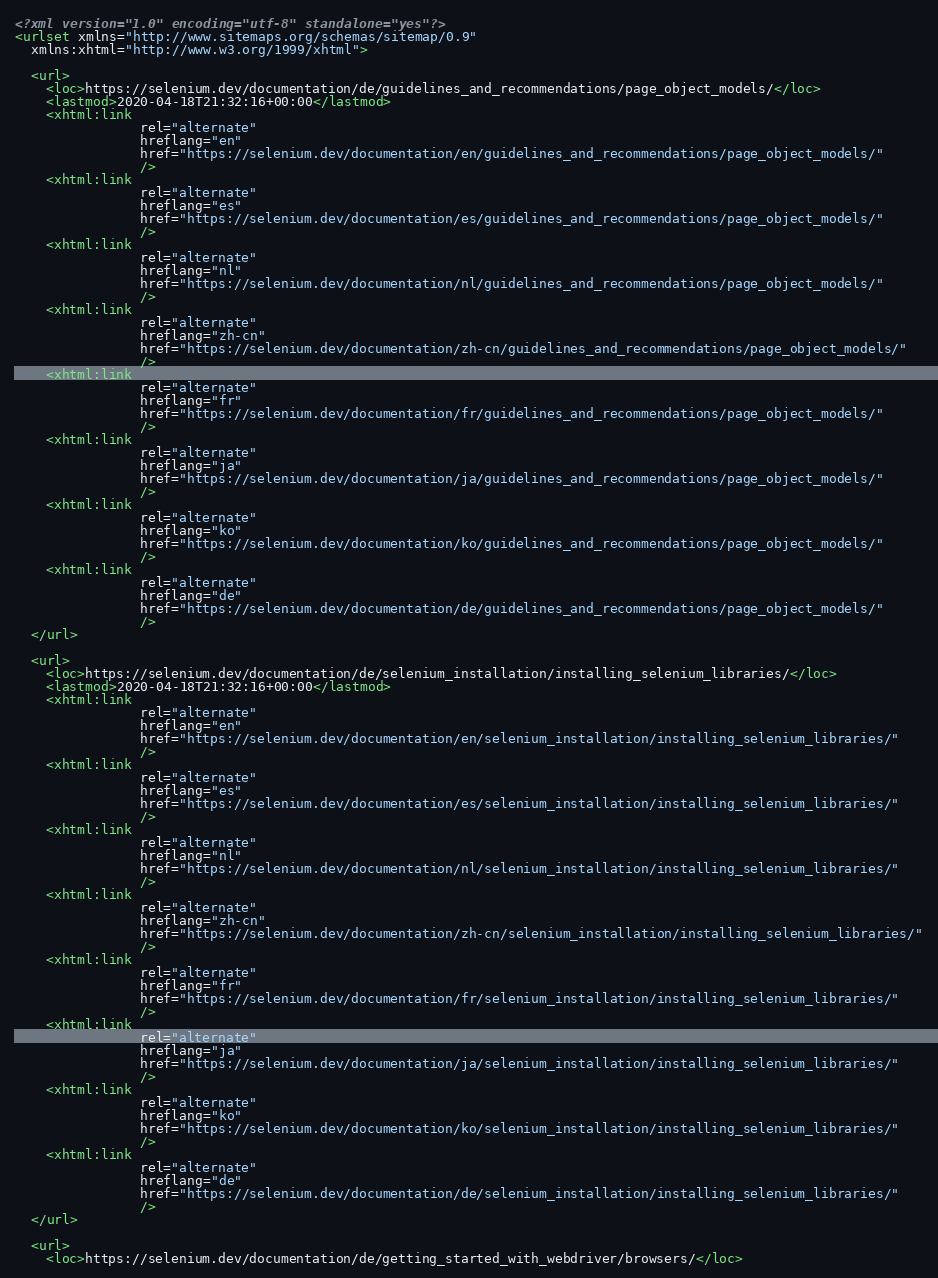Convert code to text. <code><loc_0><loc_0><loc_500><loc_500><_XML_><?xml version="1.0" encoding="utf-8" standalone="yes"?>
<urlset xmlns="http://www.sitemaps.org/schemas/sitemap/0.9"
  xmlns:xhtml="http://www.w3.org/1999/xhtml">
  
  <url>
    <loc>https://selenium.dev/documentation/de/guidelines_and_recommendations/page_object_models/</loc>
    <lastmod>2020-04-18T21:32:16+00:00</lastmod>
    <xhtml:link
                rel="alternate"
                hreflang="en"
                href="https://selenium.dev/documentation/en/guidelines_and_recommendations/page_object_models/"
                />
    <xhtml:link
                rel="alternate"
                hreflang="es"
                href="https://selenium.dev/documentation/es/guidelines_and_recommendations/page_object_models/"
                />
    <xhtml:link
                rel="alternate"
                hreflang="nl"
                href="https://selenium.dev/documentation/nl/guidelines_and_recommendations/page_object_models/"
                />
    <xhtml:link
                rel="alternate"
                hreflang="zh-cn"
                href="https://selenium.dev/documentation/zh-cn/guidelines_and_recommendations/page_object_models/"
                />
    <xhtml:link
                rel="alternate"
                hreflang="fr"
                href="https://selenium.dev/documentation/fr/guidelines_and_recommendations/page_object_models/"
                />
    <xhtml:link
                rel="alternate"
                hreflang="ja"
                href="https://selenium.dev/documentation/ja/guidelines_and_recommendations/page_object_models/"
                />
    <xhtml:link
                rel="alternate"
                hreflang="ko"
                href="https://selenium.dev/documentation/ko/guidelines_and_recommendations/page_object_models/"
                />
    <xhtml:link
                rel="alternate"
                hreflang="de"
                href="https://selenium.dev/documentation/de/guidelines_and_recommendations/page_object_models/"
                />
  </url>
  
  <url>
    <loc>https://selenium.dev/documentation/de/selenium_installation/installing_selenium_libraries/</loc>
    <lastmod>2020-04-18T21:32:16+00:00</lastmod>
    <xhtml:link
                rel="alternate"
                hreflang="en"
                href="https://selenium.dev/documentation/en/selenium_installation/installing_selenium_libraries/"
                />
    <xhtml:link
                rel="alternate"
                hreflang="es"
                href="https://selenium.dev/documentation/es/selenium_installation/installing_selenium_libraries/"
                />
    <xhtml:link
                rel="alternate"
                hreflang="nl"
                href="https://selenium.dev/documentation/nl/selenium_installation/installing_selenium_libraries/"
                />
    <xhtml:link
                rel="alternate"
                hreflang="zh-cn"
                href="https://selenium.dev/documentation/zh-cn/selenium_installation/installing_selenium_libraries/"
                />
    <xhtml:link
                rel="alternate"
                hreflang="fr"
                href="https://selenium.dev/documentation/fr/selenium_installation/installing_selenium_libraries/"
                />
    <xhtml:link
                rel="alternate"
                hreflang="ja"
                href="https://selenium.dev/documentation/ja/selenium_installation/installing_selenium_libraries/"
                />
    <xhtml:link
                rel="alternate"
                hreflang="ko"
                href="https://selenium.dev/documentation/ko/selenium_installation/installing_selenium_libraries/"
                />
    <xhtml:link
                rel="alternate"
                hreflang="de"
                href="https://selenium.dev/documentation/de/selenium_installation/installing_selenium_libraries/"
                />
  </url>
  
  <url>
    <loc>https://selenium.dev/documentation/de/getting_started_with_webdriver/browsers/</loc></code> 